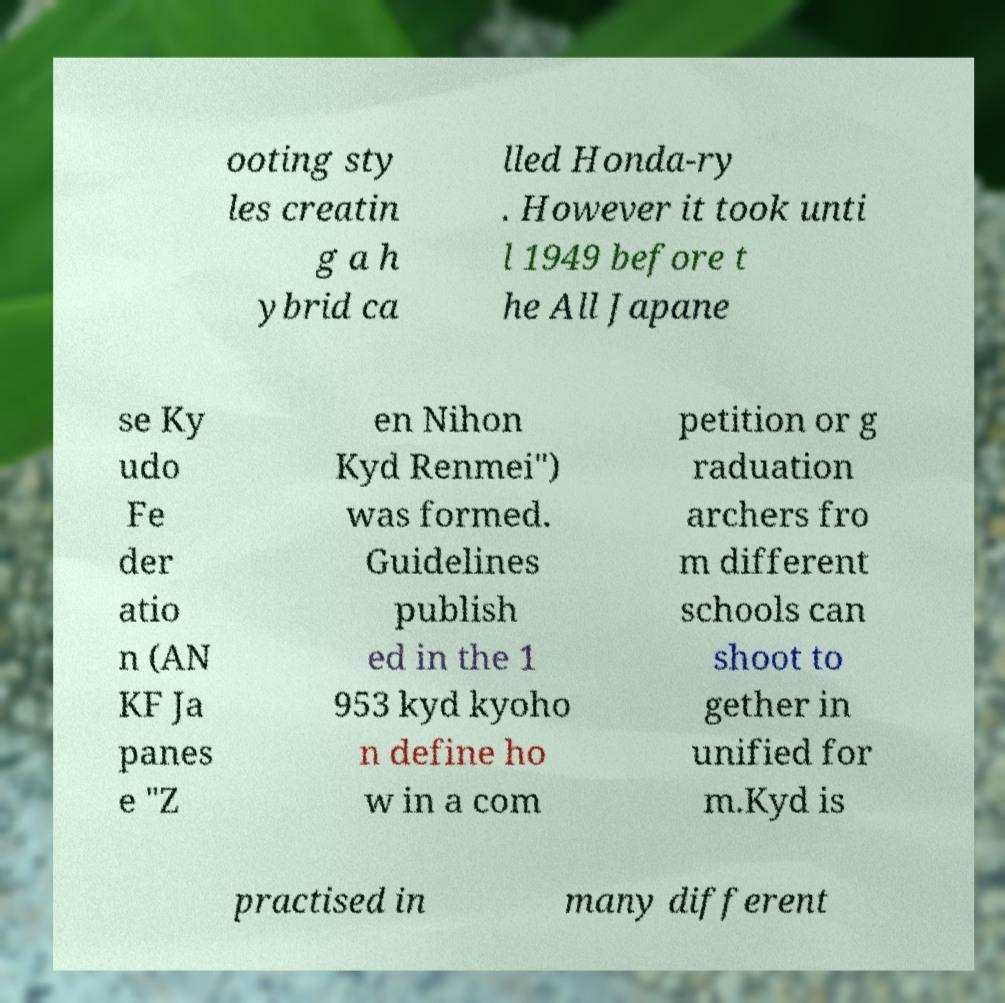Please read and relay the text visible in this image. What does it say? ooting sty les creatin g a h ybrid ca lled Honda-ry . However it took unti l 1949 before t he All Japane se Ky udo Fe der atio n (AN KF Ja panes e "Z en Nihon Kyd Renmei") was formed. Guidelines publish ed in the 1 953 kyd kyoho n define ho w in a com petition or g raduation archers fro m different schools can shoot to gether in unified for m.Kyd is practised in many different 